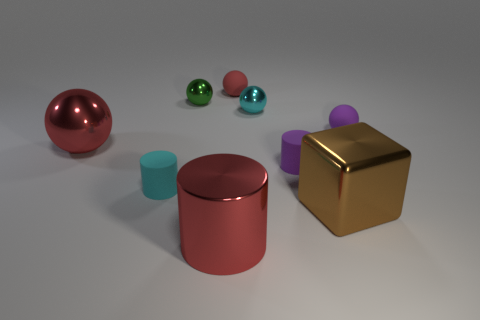How many small matte things are the same color as the large metallic sphere?
Provide a short and direct response. 1. Is the color of the cube the same as the small cylinder that is on the right side of the small red matte ball?
Your answer should be compact. No. Are there fewer tiny cyan metal objects than tiny red shiny cubes?
Provide a succinct answer. No. Are there more large red metallic things that are in front of the big brown metallic object than purple balls behind the tiny red ball?
Your answer should be compact. Yes. Are the tiny green thing and the tiny purple ball made of the same material?
Offer a terse response. No. There is a small cyan object on the right side of the tiny red rubber sphere; how many things are right of it?
Provide a succinct answer. 3. There is a metal ball that is left of the tiny green metallic thing; is its color the same as the metallic cube?
Your answer should be compact. No. How many objects are small red shiny objects or cyan objects that are behind the tiny purple matte cylinder?
Provide a short and direct response. 1. There is a large object right of the red matte object; does it have the same shape as the cyan object right of the green ball?
Provide a short and direct response. No. Are there any other things that have the same color as the large cylinder?
Your response must be concise. Yes. 